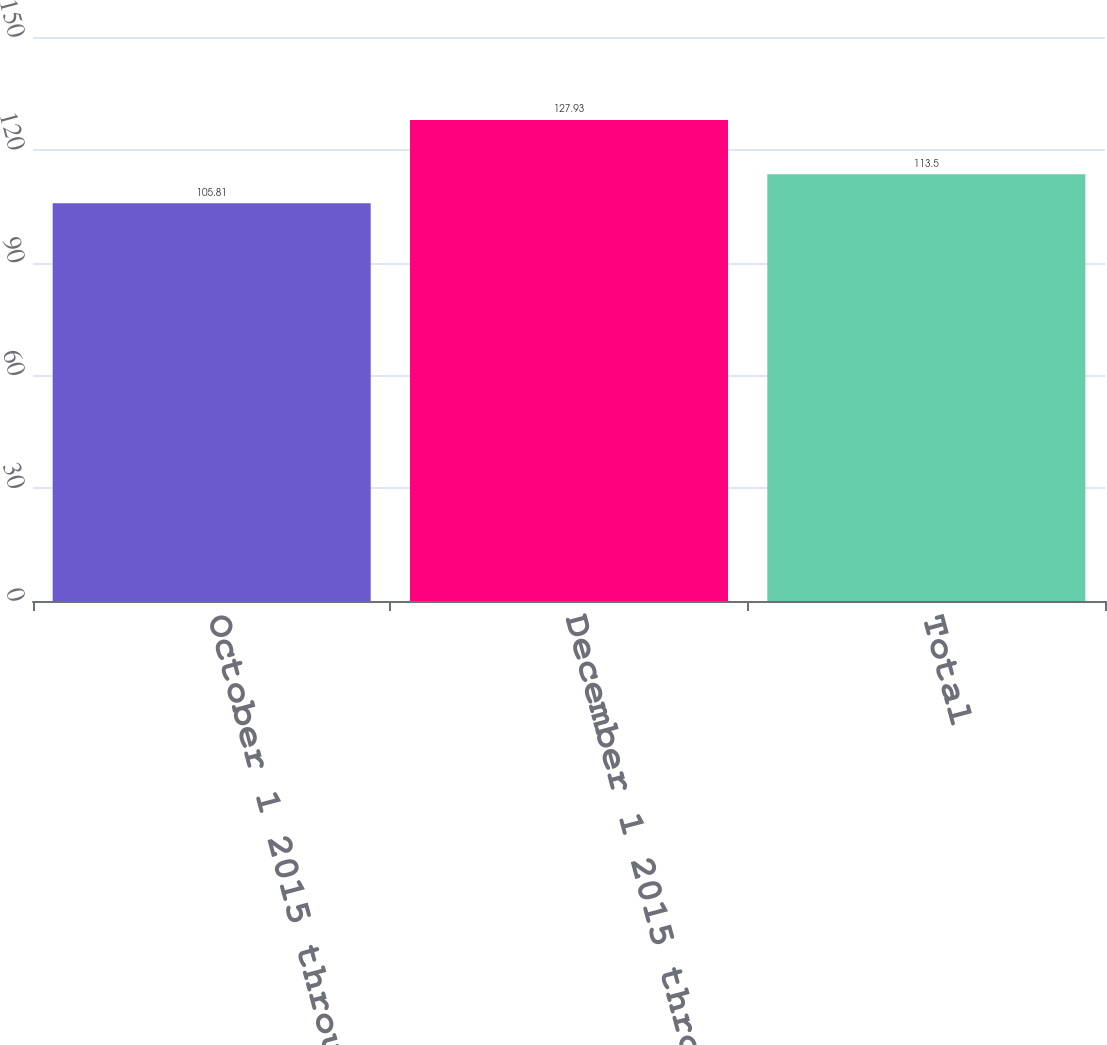<chart> <loc_0><loc_0><loc_500><loc_500><bar_chart><fcel>October 1 2015 through October<fcel>December 1 2015 through<fcel>Total<nl><fcel>105.81<fcel>127.93<fcel>113.5<nl></chart> 